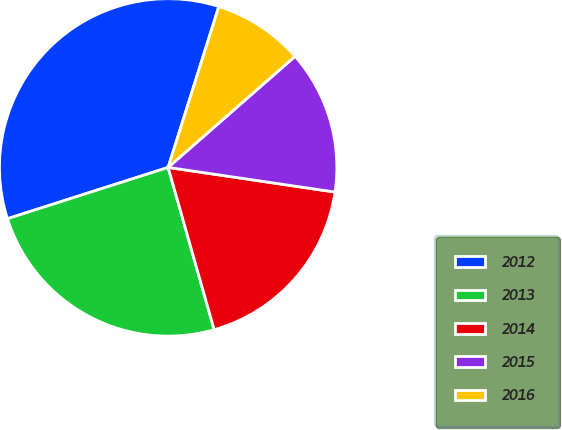Convert chart to OTSL. <chart><loc_0><loc_0><loc_500><loc_500><pie_chart><fcel>2012<fcel>2013<fcel>2014<fcel>2015<fcel>2016<nl><fcel>34.78%<fcel>24.48%<fcel>18.27%<fcel>13.78%<fcel>8.7%<nl></chart> 